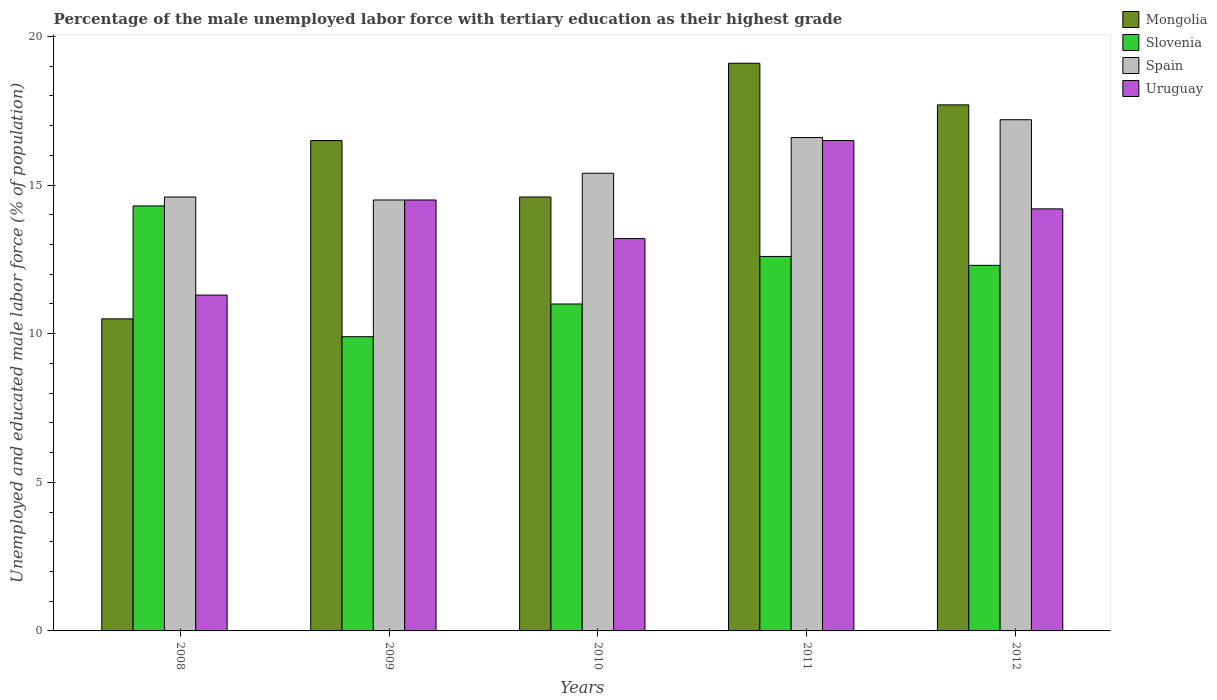How many groups of bars are there?
Ensure brevity in your answer.  5. Are the number of bars on each tick of the X-axis equal?
Your answer should be very brief. Yes. How many bars are there on the 3rd tick from the left?
Keep it short and to the point. 4. What is the percentage of the unemployed male labor force with tertiary education in Slovenia in 2011?
Your answer should be compact. 12.6. Across all years, what is the maximum percentage of the unemployed male labor force with tertiary education in Slovenia?
Give a very brief answer. 14.3. Across all years, what is the minimum percentage of the unemployed male labor force with tertiary education in Uruguay?
Your response must be concise. 11.3. In which year was the percentage of the unemployed male labor force with tertiary education in Mongolia maximum?
Keep it short and to the point. 2011. What is the total percentage of the unemployed male labor force with tertiary education in Mongolia in the graph?
Provide a succinct answer. 78.4. What is the difference between the percentage of the unemployed male labor force with tertiary education in Slovenia in 2009 and that in 2011?
Your answer should be very brief. -2.7. What is the difference between the percentage of the unemployed male labor force with tertiary education in Slovenia in 2008 and the percentage of the unemployed male labor force with tertiary education in Uruguay in 2010?
Provide a short and direct response. 1.1. What is the average percentage of the unemployed male labor force with tertiary education in Uruguay per year?
Ensure brevity in your answer.  13.94. In the year 2010, what is the difference between the percentage of the unemployed male labor force with tertiary education in Spain and percentage of the unemployed male labor force with tertiary education in Mongolia?
Keep it short and to the point. 0.8. In how many years, is the percentage of the unemployed male labor force with tertiary education in Uruguay greater than 2 %?
Your answer should be very brief. 5. What is the ratio of the percentage of the unemployed male labor force with tertiary education in Uruguay in 2010 to that in 2011?
Provide a succinct answer. 0.8. Is the difference between the percentage of the unemployed male labor force with tertiary education in Spain in 2011 and 2012 greater than the difference between the percentage of the unemployed male labor force with tertiary education in Mongolia in 2011 and 2012?
Keep it short and to the point. No. What is the difference between the highest and the lowest percentage of the unemployed male labor force with tertiary education in Slovenia?
Keep it short and to the point. 4.4. In how many years, is the percentage of the unemployed male labor force with tertiary education in Slovenia greater than the average percentage of the unemployed male labor force with tertiary education in Slovenia taken over all years?
Provide a succinct answer. 3. Is it the case that in every year, the sum of the percentage of the unemployed male labor force with tertiary education in Mongolia and percentage of the unemployed male labor force with tertiary education in Spain is greater than the sum of percentage of the unemployed male labor force with tertiary education in Uruguay and percentage of the unemployed male labor force with tertiary education in Slovenia?
Provide a succinct answer. No. What does the 1st bar from the left in 2009 represents?
Provide a succinct answer. Mongolia. What does the 4th bar from the right in 2009 represents?
Offer a terse response. Mongolia. How many bars are there?
Provide a short and direct response. 20. What is the difference between two consecutive major ticks on the Y-axis?
Your answer should be compact. 5. Are the values on the major ticks of Y-axis written in scientific E-notation?
Provide a succinct answer. No. Does the graph contain any zero values?
Your answer should be compact. No. What is the title of the graph?
Provide a short and direct response. Percentage of the male unemployed labor force with tertiary education as their highest grade. Does "Faeroe Islands" appear as one of the legend labels in the graph?
Keep it short and to the point. No. What is the label or title of the X-axis?
Provide a succinct answer. Years. What is the label or title of the Y-axis?
Ensure brevity in your answer.  Unemployed and educated male labor force (% of population). What is the Unemployed and educated male labor force (% of population) of Slovenia in 2008?
Offer a terse response. 14.3. What is the Unemployed and educated male labor force (% of population) in Spain in 2008?
Ensure brevity in your answer.  14.6. What is the Unemployed and educated male labor force (% of population) in Uruguay in 2008?
Your answer should be very brief. 11.3. What is the Unemployed and educated male labor force (% of population) of Mongolia in 2009?
Provide a succinct answer. 16.5. What is the Unemployed and educated male labor force (% of population) of Slovenia in 2009?
Provide a short and direct response. 9.9. What is the Unemployed and educated male labor force (% of population) of Uruguay in 2009?
Offer a very short reply. 14.5. What is the Unemployed and educated male labor force (% of population) in Mongolia in 2010?
Your answer should be very brief. 14.6. What is the Unemployed and educated male labor force (% of population) in Slovenia in 2010?
Your answer should be very brief. 11. What is the Unemployed and educated male labor force (% of population) in Spain in 2010?
Your response must be concise. 15.4. What is the Unemployed and educated male labor force (% of population) in Uruguay in 2010?
Ensure brevity in your answer.  13.2. What is the Unemployed and educated male labor force (% of population) of Mongolia in 2011?
Offer a terse response. 19.1. What is the Unemployed and educated male labor force (% of population) of Slovenia in 2011?
Provide a short and direct response. 12.6. What is the Unemployed and educated male labor force (% of population) of Spain in 2011?
Provide a succinct answer. 16.6. What is the Unemployed and educated male labor force (% of population) in Uruguay in 2011?
Offer a terse response. 16.5. What is the Unemployed and educated male labor force (% of population) in Mongolia in 2012?
Your answer should be very brief. 17.7. What is the Unemployed and educated male labor force (% of population) in Slovenia in 2012?
Offer a very short reply. 12.3. What is the Unemployed and educated male labor force (% of population) of Spain in 2012?
Make the answer very short. 17.2. What is the Unemployed and educated male labor force (% of population) of Uruguay in 2012?
Keep it short and to the point. 14.2. Across all years, what is the maximum Unemployed and educated male labor force (% of population) of Mongolia?
Your answer should be very brief. 19.1. Across all years, what is the maximum Unemployed and educated male labor force (% of population) of Slovenia?
Keep it short and to the point. 14.3. Across all years, what is the maximum Unemployed and educated male labor force (% of population) in Spain?
Ensure brevity in your answer.  17.2. Across all years, what is the maximum Unemployed and educated male labor force (% of population) of Uruguay?
Your answer should be compact. 16.5. Across all years, what is the minimum Unemployed and educated male labor force (% of population) of Slovenia?
Your answer should be very brief. 9.9. Across all years, what is the minimum Unemployed and educated male labor force (% of population) in Spain?
Keep it short and to the point. 14.5. Across all years, what is the minimum Unemployed and educated male labor force (% of population) of Uruguay?
Your answer should be compact. 11.3. What is the total Unemployed and educated male labor force (% of population) in Mongolia in the graph?
Your response must be concise. 78.4. What is the total Unemployed and educated male labor force (% of population) in Slovenia in the graph?
Your response must be concise. 60.1. What is the total Unemployed and educated male labor force (% of population) in Spain in the graph?
Offer a very short reply. 78.3. What is the total Unemployed and educated male labor force (% of population) of Uruguay in the graph?
Provide a short and direct response. 69.7. What is the difference between the Unemployed and educated male labor force (% of population) in Mongolia in 2008 and that in 2009?
Your answer should be very brief. -6. What is the difference between the Unemployed and educated male labor force (% of population) of Uruguay in 2008 and that in 2009?
Give a very brief answer. -3.2. What is the difference between the Unemployed and educated male labor force (% of population) in Slovenia in 2008 and that in 2010?
Provide a succinct answer. 3.3. What is the difference between the Unemployed and educated male labor force (% of population) in Mongolia in 2008 and that in 2011?
Ensure brevity in your answer.  -8.6. What is the difference between the Unemployed and educated male labor force (% of population) of Spain in 2008 and that in 2011?
Provide a short and direct response. -2. What is the difference between the Unemployed and educated male labor force (% of population) of Uruguay in 2008 and that in 2011?
Ensure brevity in your answer.  -5.2. What is the difference between the Unemployed and educated male labor force (% of population) of Mongolia in 2009 and that in 2010?
Your answer should be very brief. 1.9. What is the difference between the Unemployed and educated male labor force (% of population) of Spain in 2009 and that in 2010?
Make the answer very short. -0.9. What is the difference between the Unemployed and educated male labor force (% of population) of Uruguay in 2009 and that in 2010?
Offer a terse response. 1.3. What is the difference between the Unemployed and educated male labor force (% of population) of Mongolia in 2009 and that in 2011?
Your answer should be very brief. -2.6. What is the difference between the Unemployed and educated male labor force (% of population) in Slovenia in 2009 and that in 2011?
Provide a succinct answer. -2.7. What is the difference between the Unemployed and educated male labor force (% of population) in Spain in 2009 and that in 2011?
Keep it short and to the point. -2.1. What is the difference between the Unemployed and educated male labor force (% of population) of Uruguay in 2009 and that in 2012?
Your answer should be very brief. 0.3. What is the difference between the Unemployed and educated male labor force (% of population) in Mongolia in 2010 and that in 2011?
Keep it short and to the point. -4.5. What is the difference between the Unemployed and educated male labor force (% of population) in Slovenia in 2010 and that in 2011?
Make the answer very short. -1.6. What is the difference between the Unemployed and educated male labor force (% of population) of Spain in 2010 and that in 2011?
Give a very brief answer. -1.2. What is the difference between the Unemployed and educated male labor force (% of population) in Slovenia in 2010 and that in 2012?
Provide a short and direct response. -1.3. What is the difference between the Unemployed and educated male labor force (% of population) of Spain in 2010 and that in 2012?
Offer a very short reply. -1.8. What is the difference between the Unemployed and educated male labor force (% of population) of Uruguay in 2010 and that in 2012?
Ensure brevity in your answer.  -1. What is the difference between the Unemployed and educated male labor force (% of population) of Mongolia in 2008 and the Unemployed and educated male labor force (% of population) of Slovenia in 2009?
Make the answer very short. 0.6. What is the difference between the Unemployed and educated male labor force (% of population) of Mongolia in 2008 and the Unemployed and educated male labor force (% of population) of Spain in 2009?
Make the answer very short. -4. What is the difference between the Unemployed and educated male labor force (% of population) in Slovenia in 2008 and the Unemployed and educated male labor force (% of population) in Spain in 2009?
Your answer should be very brief. -0.2. What is the difference between the Unemployed and educated male labor force (% of population) of Slovenia in 2008 and the Unemployed and educated male labor force (% of population) of Uruguay in 2009?
Your answer should be very brief. -0.2. What is the difference between the Unemployed and educated male labor force (% of population) in Mongolia in 2008 and the Unemployed and educated male labor force (% of population) in Slovenia in 2010?
Keep it short and to the point. -0.5. What is the difference between the Unemployed and educated male labor force (% of population) of Mongolia in 2008 and the Unemployed and educated male labor force (% of population) of Spain in 2010?
Your response must be concise. -4.9. What is the difference between the Unemployed and educated male labor force (% of population) of Slovenia in 2008 and the Unemployed and educated male labor force (% of population) of Spain in 2010?
Offer a very short reply. -1.1. What is the difference between the Unemployed and educated male labor force (% of population) in Slovenia in 2008 and the Unemployed and educated male labor force (% of population) in Uruguay in 2010?
Provide a short and direct response. 1.1. What is the difference between the Unemployed and educated male labor force (% of population) in Spain in 2008 and the Unemployed and educated male labor force (% of population) in Uruguay in 2010?
Provide a short and direct response. 1.4. What is the difference between the Unemployed and educated male labor force (% of population) in Mongolia in 2008 and the Unemployed and educated male labor force (% of population) in Spain in 2011?
Offer a very short reply. -6.1. What is the difference between the Unemployed and educated male labor force (% of population) of Mongolia in 2008 and the Unemployed and educated male labor force (% of population) of Uruguay in 2011?
Ensure brevity in your answer.  -6. What is the difference between the Unemployed and educated male labor force (% of population) of Spain in 2008 and the Unemployed and educated male labor force (% of population) of Uruguay in 2011?
Provide a short and direct response. -1.9. What is the difference between the Unemployed and educated male labor force (% of population) of Mongolia in 2008 and the Unemployed and educated male labor force (% of population) of Slovenia in 2012?
Provide a succinct answer. -1.8. What is the difference between the Unemployed and educated male labor force (% of population) in Mongolia in 2008 and the Unemployed and educated male labor force (% of population) in Spain in 2012?
Provide a short and direct response. -6.7. What is the difference between the Unemployed and educated male labor force (% of population) in Slovenia in 2008 and the Unemployed and educated male labor force (% of population) in Spain in 2012?
Offer a very short reply. -2.9. What is the difference between the Unemployed and educated male labor force (% of population) in Slovenia in 2008 and the Unemployed and educated male labor force (% of population) in Uruguay in 2012?
Your response must be concise. 0.1. What is the difference between the Unemployed and educated male labor force (% of population) of Mongolia in 2009 and the Unemployed and educated male labor force (% of population) of Slovenia in 2010?
Keep it short and to the point. 5.5. What is the difference between the Unemployed and educated male labor force (% of population) in Mongolia in 2009 and the Unemployed and educated male labor force (% of population) in Uruguay in 2010?
Give a very brief answer. 3.3. What is the difference between the Unemployed and educated male labor force (% of population) of Slovenia in 2009 and the Unemployed and educated male labor force (% of population) of Spain in 2010?
Offer a terse response. -5.5. What is the difference between the Unemployed and educated male labor force (% of population) in Mongolia in 2009 and the Unemployed and educated male labor force (% of population) in Uruguay in 2011?
Provide a succinct answer. 0. What is the difference between the Unemployed and educated male labor force (% of population) of Mongolia in 2009 and the Unemployed and educated male labor force (% of population) of Uruguay in 2012?
Offer a very short reply. 2.3. What is the difference between the Unemployed and educated male labor force (% of population) in Slovenia in 2009 and the Unemployed and educated male labor force (% of population) in Spain in 2012?
Provide a short and direct response. -7.3. What is the difference between the Unemployed and educated male labor force (% of population) of Slovenia in 2009 and the Unemployed and educated male labor force (% of population) of Uruguay in 2012?
Provide a succinct answer. -4.3. What is the difference between the Unemployed and educated male labor force (% of population) in Spain in 2009 and the Unemployed and educated male labor force (% of population) in Uruguay in 2012?
Provide a short and direct response. 0.3. What is the difference between the Unemployed and educated male labor force (% of population) in Mongolia in 2010 and the Unemployed and educated male labor force (% of population) in Slovenia in 2011?
Make the answer very short. 2. What is the difference between the Unemployed and educated male labor force (% of population) in Mongolia in 2010 and the Unemployed and educated male labor force (% of population) in Slovenia in 2012?
Offer a very short reply. 2.3. What is the difference between the Unemployed and educated male labor force (% of population) in Slovenia in 2010 and the Unemployed and educated male labor force (% of population) in Spain in 2012?
Ensure brevity in your answer.  -6.2. What is the difference between the Unemployed and educated male labor force (% of population) of Spain in 2010 and the Unemployed and educated male labor force (% of population) of Uruguay in 2012?
Provide a succinct answer. 1.2. What is the difference between the Unemployed and educated male labor force (% of population) in Mongolia in 2011 and the Unemployed and educated male labor force (% of population) in Spain in 2012?
Make the answer very short. 1.9. What is the difference between the Unemployed and educated male labor force (% of population) in Mongolia in 2011 and the Unemployed and educated male labor force (% of population) in Uruguay in 2012?
Keep it short and to the point. 4.9. What is the difference between the Unemployed and educated male labor force (% of population) of Spain in 2011 and the Unemployed and educated male labor force (% of population) of Uruguay in 2012?
Give a very brief answer. 2.4. What is the average Unemployed and educated male labor force (% of population) in Mongolia per year?
Make the answer very short. 15.68. What is the average Unemployed and educated male labor force (% of population) of Slovenia per year?
Provide a succinct answer. 12.02. What is the average Unemployed and educated male labor force (% of population) in Spain per year?
Provide a succinct answer. 15.66. What is the average Unemployed and educated male labor force (% of population) of Uruguay per year?
Your response must be concise. 13.94. In the year 2008, what is the difference between the Unemployed and educated male labor force (% of population) of Mongolia and Unemployed and educated male labor force (% of population) of Slovenia?
Keep it short and to the point. -3.8. In the year 2008, what is the difference between the Unemployed and educated male labor force (% of population) of Mongolia and Unemployed and educated male labor force (% of population) of Uruguay?
Provide a succinct answer. -0.8. In the year 2008, what is the difference between the Unemployed and educated male labor force (% of population) of Slovenia and Unemployed and educated male labor force (% of population) of Spain?
Make the answer very short. -0.3. In the year 2008, what is the difference between the Unemployed and educated male labor force (% of population) of Slovenia and Unemployed and educated male labor force (% of population) of Uruguay?
Provide a short and direct response. 3. In the year 2009, what is the difference between the Unemployed and educated male labor force (% of population) of Mongolia and Unemployed and educated male labor force (% of population) of Uruguay?
Give a very brief answer. 2. In the year 2009, what is the difference between the Unemployed and educated male labor force (% of population) of Slovenia and Unemployed and educated male labor force (% of population) of Spain?
Keep it short and to the point. -4.6. In the year 2009, what is the difference between the Unemployed and educated male labor force (% of population) of Slovenia and Unemployed and educated male labor force (% of population) of Uruguay?
Provide a succinct answer. -4.6. In the year 2009, what is the difference between the Unemployed and educated male labor force (% of population) of Spain and Unemployed and educated male labor force (% of population) of Uruguay?
Ensure brevity in your answer.  0. In the year 2010, what is the difference between the Unemployed and educated male labor force (% of population) of Mongolia and Unemployed and educated male labor force (% of population) of Spain?
Provide a short and direct response. -0.8. In the year 2010, what is the difference between the Unemployed and educated male labor force (% of population) of Slovenia and Unemployed and educated male labor force (% of population) of Uruguay?
Make the answer very short. -2.2. In the year 2011, what is the difference between the Unemployed and educated male labor force (% of population) of Mongolia and Unemployed and educated male labor force (% of population) of Spain?
Offer a terse response. 2.5. In the year 2011, what is the difference between the Unemployed and educated male labor force (% of population) in Mongolia and Unemployed and educated male labor force (% of population) in Uruguay?
Provide a short and direct response. 2.6. In the year 2011, what is the difference between the Unemployed and educated male labor force (% of population) in Slovenia and Unemployed and educated male labor force (% of population) in Uruguay?
Your answer should be very brief. -3.9. In the year 2011, what is the difference between the Unemployed and educated male labor force (% of population) of Spain and Unemployed and educated male labor force (% of population) of Uruguay?
Make the answer very short. 0.1. In the year 2012, what is the difference between the Unemployed and educated male labor force (% of population) in Spain and Unemployed and educated male labor force (% of population) in Uruguay?
Make the answer very short. 3. What is the ratio of the Unemployed and educated male labor force (% of population) of Mongolia in 2008 to that in 2009?
Give a very brief answer. 0.64. What is the ratio of the Unemployed and educated male labor force (% of population) of Slovenia in 2008 to that in 2009?
Provide a succinct answer. 1.44. What is the ratio of the Unemployed and educated male labor force (% of population) of Uruguay in 2008 to that in 2009?
Offer a terse response. 0.78. What is the ratio of the Unemployed and educated male labor force (% of population) in Mongolia in 2008 to that in 2010?
Keep it short and to the point. 0.72. What is the ratio of the Unemployed and educated male labor force (% of population) in Slovenia in 2008 to that in 2010?
Make the answer very short. 1.3. What is the ratio of the Unemployed and educated male labor force (% of population) of Spain in 2008 to that in 2010?
Ensure brevity in your answer.  0.95. What is the ratio of the Unemployed and educated male labor force (% of population) in Uruguay in 2008 to that in 2010?
Provide a succinct answer. 0.86. What is the ratio of the Unemployed and educated male labor force (% of population) of Mongolia in 2008 to that in 2011?
Provide a succinct answer. 0.55. What is the ratio of the Unemployed and educated male labor force (% of population) of Slovenia in 2008 to that in 2011?
Offer a terse response. 1.13. What is the ratio of the Unemployed and educated male labor force (% of population) of Spain in 2008 to that in 2011?
Your answer should be very brief. 0.88. What is the ratio of the Unemployed and educated male labor force (% of population) of Uruguay in 2008 to that in 2011?
Provide a short and direct response. 0.68. What is the ratio of the Unemployed and educated male labor force (% of population) of Mongolia in 2008 to that in 2012?
Offer a terse response. 0.59. What is the ratio of the Unemployed and educated male labor force (% of population) of Slovenia in 2008 to that in 2012?
Ensure brevity in your answer.  1.16. What is the ratio of the Unemployed and educated male labor force (% of population) in Spain in 2008 to that in 2012?
Ensure brevity in your answer.  0.85. What is the ratio of the Unemployed and educated male labor force (% of population) of Uruguay in 2008 to that in 2012?
Your answer should be very brief. 0.8. What is the ratio of the Unemployed and educated male labor force (% of population) in Mongolia in 2009 to that in 2010?
Provide a succinct answer. 1.13. What is the ratio of the Unemployed and educated male labor force (% of population) in Spain in 2009 to that in 2010?
Your answer should be compact. 0.94. What is the ratio of the Unemployed and educated male labor force (% of population) of Uruguay in 2009 to that in 2010?
Offer a very short reply. 1.1. What is the ratio of the Unemployed and educated male labor force (% of population) of Mongolia in 2009 to that in 2011?
Keep it short and to the point. 0.86. What is the ratio of the Unemployed and educated male labor force (% of population) in Slovenia in 2009 to that in 2011?
Your response must be concise. 0.79. What is the ratio of the Unemployed and educated male labor force (% of population) in Spain in 2009 to that in 2011?
Offer a terse response. 0.87. What is the ratio of the Unemployed and educated male labor force (% of population) in Uruguay in 2009 to that in 2011?
Make the answer very short. 0.88. What is the ratio of the Unemployed and educated male labor force (% of population) in Mongolia in 2009 to that in 2012?
Your answer should be very brief. 0.93. What is the ratio of the Unemployed and educated male labor force (% of population) in Slovenia in 2009 to that in 2012?
Give a very brief answer. 0.8. What is the ratio of the Unemployed and educated male labor force (% of population) of Spain in 2009 to that in 2012?
Your answer should be compact. 0.84. What is the ratio of the Unemployed and educated male labor force (% of population) of Uruguay in 2009 to that in 2012?
Give a very brief answer. 1.02. What is the ratio of the Unemployed and educated male labor force (% of population) of Mongolia in 2010 to that in 2011?
Your answer should be very brief. 0.76. What is the ratio of the Unemployed and educated male labor force (% of population) of Slovenia in 2010 to that in 2011?
Keep it short and to the point. 0.87. What is the ratio of the Unemployed and educated male labor force (% of population) of Spain in 2010 to that in 2011?
Provide a succinct answer. 0.93. What is the ratio of the Unemployed and educated male labor force (% of population) in Uruguay in 2010 to that in 2011?
Offer a terse response. 0.8. What is the ratio of the Unemployed and educated male labor force (% of population) in Mongolia in 2010 to that in 2012?
Your answer should be very brief. 0.82. What is the ratio of the Unemployed and educated male labor force (% of population) in Slovenia in 2010 to that in 2012?
Your answer should be very brief. 0.89. What is the ratio of the Unemployed and educated male labor force (% of population) of Spain in 2010 to that in 2012?
Keep it short and to the point. 0.9. What is the ratio of the Unemployed and educated male labor force (% of population) in Uruguay in 2010 to that in 2012?
Offer a very short reply. 0.93. What is the ratio of the Unemployed and educated male labor force (% of population) in Mongolia in 2011 to that in 2012?
Your answer should be compact. 1.08. What is the ratio of the Unemployed and educated male labor force (% of population) in Slovenia in 2011 to that in 2012?
Ensure brevity in your answer.  1.02. What is the ratio of the Unemployed and educated male labor force (% of population) of Spain in 2011 to that in 2012?
Make the answer very short. 0.97. What is the ratio of the Unemployed and educated male labor force (% of population) in Uruguay in 2011 to that in 2012?
Your answer should be compact. 1.16. What is the difference between the highest and the second highest Unemployed and educated male labor force (% of population) of Mongolia?
Ensure brevity in your answer.  1.4. What is the difference between the highest and the second highest Unemployed and educated male labor force (% of population) of Slovenia?
Make the answer very short. 1.7. What is the difference between the highest and the second highest Unemployed and educated male labor force (% of population) in Spain?
Keep it short and to the point. 0.6. What is the difference between the highest and the second highest Unemployed and educated male labor force (% of population) of Uruguay?
Your answer should be compact. 2. What is the difference between the highest and the lowest Unemployed and educated male labor force (% of population) in Slovenia?
Provide a short and direct response. 4.4. 